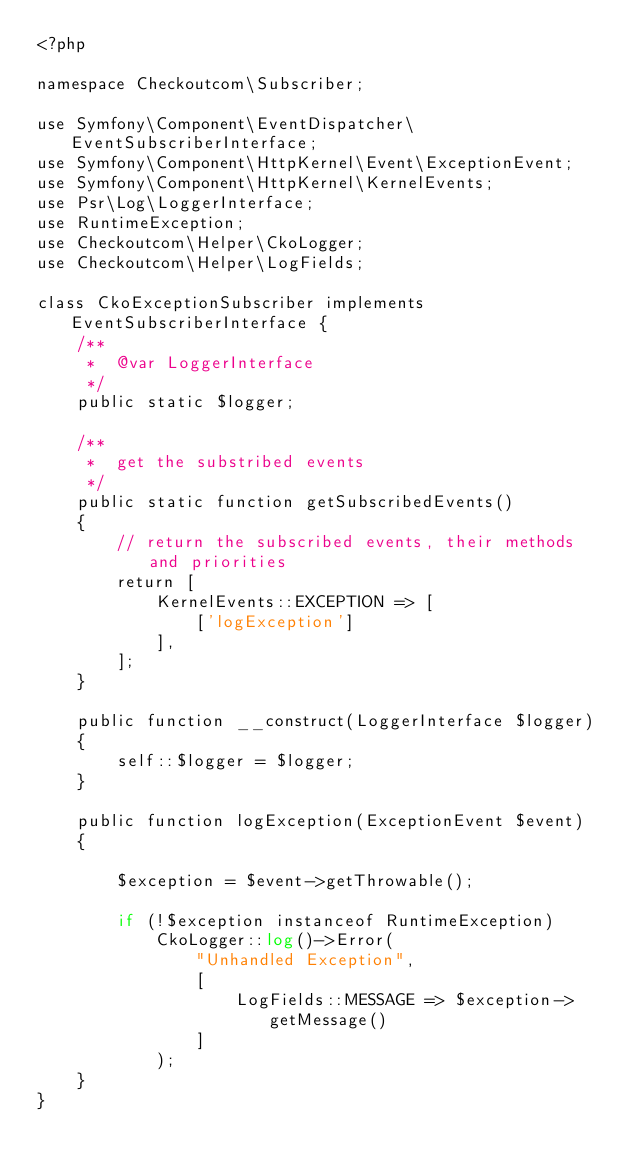Convert code to text. <code><loc_0><loc_0><loc_500><loc_500><_PHP_><?php

namespace Checkoutcom\Subscriber;

use Symfony\Component\EventDispatcher\EventSubscriberInterface;
use Symfony\Component\HttpKernel\Event\ExceptionEvent;
use Symfony\Component\HttpKernel\KernelEvents;
use Psr\Log\LoggerInterface;
use RuntimeException;
use Checkoutcom\Helper\CkoLogger;
use Checkoutcom\Helper\LogFields;

class CkoExceptionSubscriber implements EventSubscriberInterface {
    /**
     *  @var LoggerInterface
     */
    public static $logger;

    /**
     *  get the substribed events
     */
    public static function getSubscribedEvents()
    {
        // return the subscribed events, their methods and priorities
        return [
            KernelEvents::EXCEPTION => [
                ['logException']
            ],
        ];
    }

    public function __construct(LoggerInterface $logger)
    {
        self::$logger = $logger;
    }

    public function logException(ExceptionEvent $event)
    {

        $exception = $event->getThrowable();

        if (!$exception instanceof RuntimeException)
            CkoLogger::log()->Error(
                "Unhandled Exception",
                [
                    LogFields::MESSAGE => $exception->getMessage()
                ]
            );
    }
}</code> 